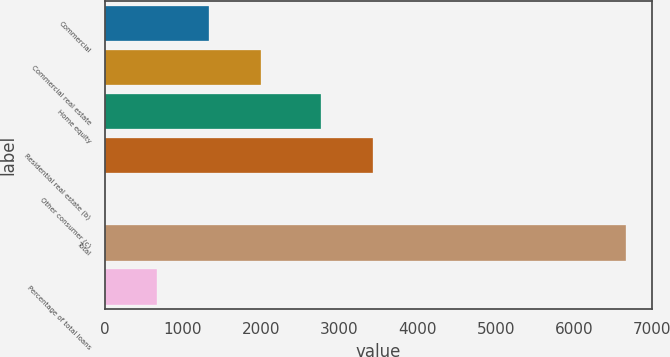<chart> <loc_0><loc_0><loc_500><loc_500><bar_chart><fcel>Commercial<fcel>Commercial real estate<fcel>Home equity<fcel>Residential real estate (b)<fcel>Other consumer (c)<fcel>Total<fcel>Percentage of total loans<nl><fcel>1335<fcel>2001.5<fcel>2764<fcel>3430.5<fcel>2<fcel>6667<fcel>668.5<nl></chart> 